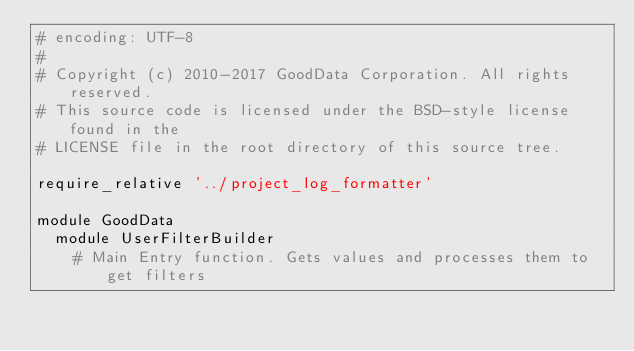Convert code to text. <code><loc_0><loc_0><loc_500><loc_500><_Ruby_># encoding: UTF-8
#
# Copyright (c) 2010-2017 GoodData Corporation. All rights reserved.
# This source code is licensed under the BSD-style license found in the
# LICENSE file in the root directory of this source tree.

require_relative '../project_log_formatter'

module GoodData
  module UserFilterBuilder
    # Main Entry function. Gets values and processes them to get filters</code> 